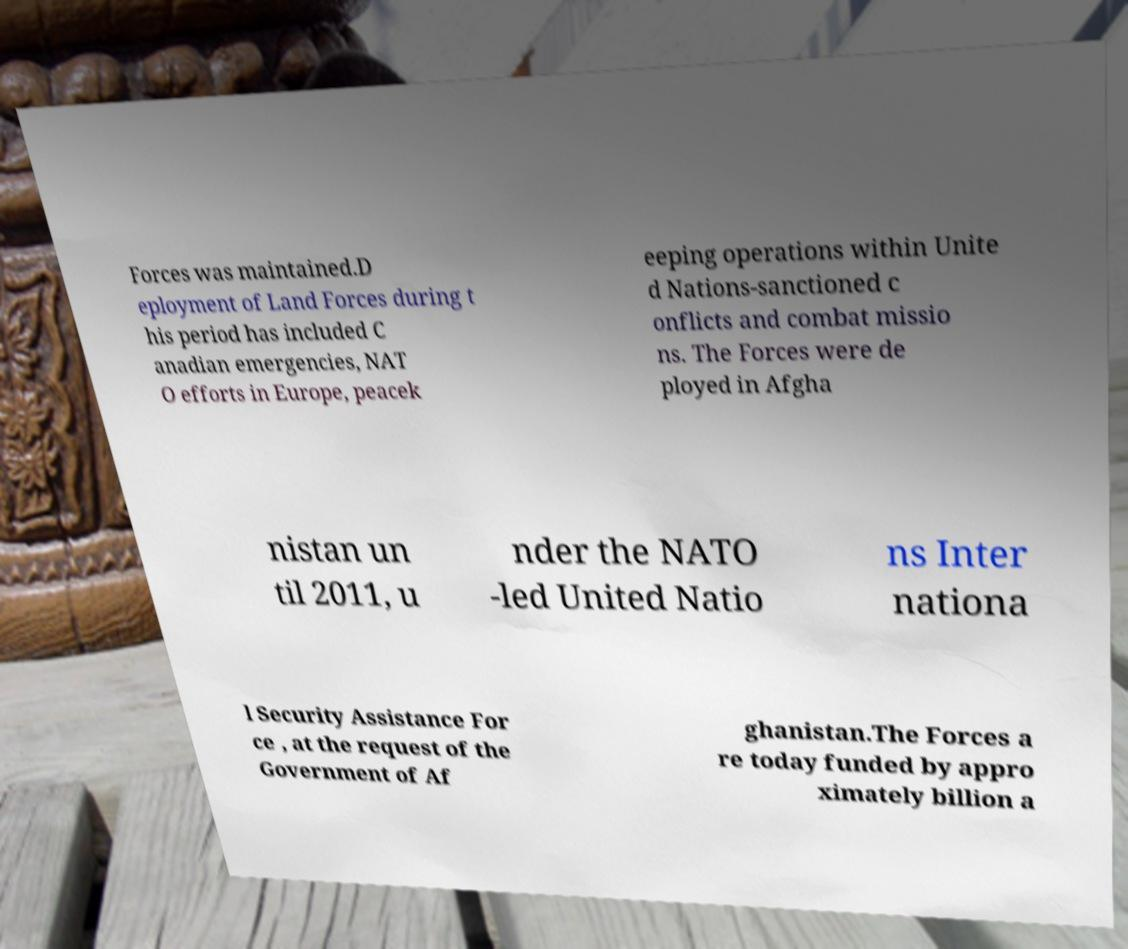Can you accurately transcribe the text from the provided image for me? Forces was maintained.D eployment of Land Forces during t his period has included C anadian emergencies, NAT O efforts in Europe, peacek eeping operations within Unite d Nations-sanctioned c onflicts and combat missio ns. The Forces were de ployed in Afgha nistan un til 2011, u nder the NATO -led United Natio ns Inter nationa l Security Assistance For ce , at the request of the Government of Af ghanistan.The Forces a re today funded by appro ximately billion a 